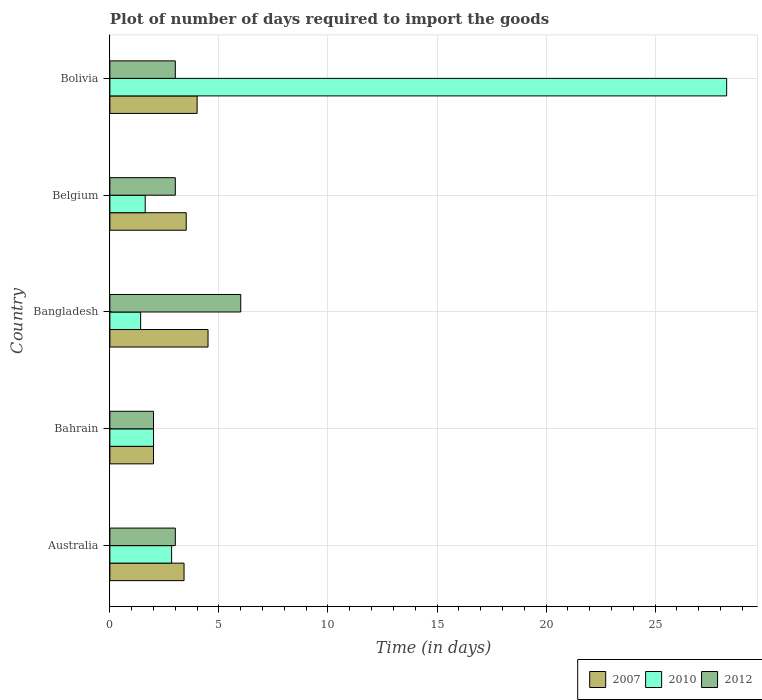How many groups of bars are there?
Your answer should be compact. 5. Are the number of bars per tick equal to the number of legend labels?
Keep it short and to the point. Yes. How many bars are there on the 5th tick from the bottom?
Your answer should be very brief. 3. What is the label of the 5th group of bars from the top?
Ensure brevity in your answer.  Australia. In how many cases, is the number of bars for a given country not equal to the number of legend labels?
Your answer should be compact. 0. What is the time required to import goods in 2007 in Belgium?
Give a very brief answer. 3.5. Across all countries, what is the minimum time required to import goods in 2010?
Keep it short and to the point. 1.41. In which country was the time required to import goods in 2012 maximum?
Offer a very short reply. Bangladesh. In which country was the time required to import goods in 2010 minimum?
Provide a short and direct response. Bangladesh. What is the difference between the time required to import goods in 2010 in Australia and that in Belgium?
Offer a very short reply. 1.21. What is the difference between the time required to import goods in 2012 in Bangladesh and the time required to import goods in 2010 in Australia?
Keep it short and to the point. 3.17. What is the average time required to import goods in 2010 per country?
Offer a very short reply. 7.23. What is the difference between the time required to import goods in 2007 and time required to import goods in 2010 in Bahrain?
Offer a very short reply. 0. Is the time required to import goods in 2007 in Bangladesh less than that in Bolivia?
Provide a short and direct response. No. What is the difference between the highest and the second highest time required to import goods in 2007?
Keep it short and to the point. 0.5. In how many countries, is the time required to import goods in 2010 greater than the average time required to import goods in 2010 taken over all countries?
Give a very brief answer. 1. Is the sum of the time required to import goods in 2007 in Bahrain and Bolivia greater than the maximum time required to import goods in 2012 across all countries?
Offer a very short reply. No. What does the 2nd bar from the top in Australia represents?
Provide a short and direct response. 2010. Is it the case that in every country, the sum of the time required to import goods in 2010 and time required to import goods in 2012 is greater than the time required to import goods in 2007?
Give a very brief answer. Yes. How many bars are there?
Make the answer very short. 15. What is the difference between two consecutive major ticks on the X-axis?
Make the answer very short. 5. What is the title of the graph?
Offer a terse response. Plot of number of days required to import the goods. What is the label or title of the X-axis?
Give a very brief answer. Time (in days). What is the Time (in days) of 2007 in Australia?
Make the answer very short. 3.4. What is the Time (in days) of 2010 in Australia?
Your answer should be compact. 2.83. What is the Time (in days) in 2007 in Bahrain?
Provide a succinct answer. 2. What is the Time (in days) of 2010 in Bahrain?
Your answer should be compact. 2. What is the Time (in days) of 2012 in Bahrain?
Your response must be concise. 2. What is the Time (in days) in 2010 in Bangladesh?
Make the answer very short. 1.41. What is the Time (in days) of 2012 in Bangladesh?
Provide a succinct answer. 6. What is the Time (in days) of 2010 in Belgium?
Keep it short and to the point. 1.62. What is the Time (in days) of 2007 in Bolivia?
Your answer should be compact. 4. What is the Time (in days) of 2010 in Bolivia?
Provide a succinct answer. 28.28. What is the Time (in days) in 2012 in Bolivia?
Give a very brief answer. 3. Across all countries, what is the maximum Time (in days) in 2010?
Offer a very short reply. 28.28. Across all countries, what is the minimum Time (in days) of 2010?
Your answer should be very brief. 1.41. Across all countries, what is the minimum Time (in days) of 2012?
Ensure brevity in your answer.  2. What is the total Time (in days) in 2010 in the graph?
Make the answer very short. 36.14. What is the difference between the Time (in days) in 2007 in Australia and that in Bahrain?
Offer a very short reply. 1.4. What is the difference between the Time (in days) of 2010 in Australia and that in Bahrain?
Keep it short and to the point. 0.83. What is the difference between the Time (in days) of 2012 in Australia and that in Bahrain?
Provide a short and direct response. 1. What is the difference between the Time (in days) of 2010 in Australia and that in Bangladesh?
Provide a short and direct response. 1.42. What is the difference between the Time (in days) of 2007 in Australia and that in Belgium?
Ensure brevity in your answer.  -0.1. What is the difference between the Time (in days) of 2010 in Australia and that in Belgium?
Your answer should be very brief. 1.21. What is the difference between the Time (in days) in 2012 in Australia and that in Belgium?
Provide a succinct answer. 0. What is the difference between the Time (in days) of 2010 in Australia and that in Bolivia?
Ensure brevity in your answer.  -25.45. What is the difference between the Time (in days) in 2012 in Australia and that in Bolivia?
Your response must be concise. 0. What is the difference between the Time (in days) of 2010 in Bahrain and that in Bangladesh?
Offer a terse response. 0.59. What is the difference between the Time (in days) in 2010 in Bahrain and that in Belgium?
Ensure brevity in your answer.  0.38. What is the difference between the Time (in days) in 2010 in Bahrain and that in Bolivia?
Provide a short and direct response. -26.28. What is the difference between the Time (in days) in 2010 in Bangladesh and that in Belgium?
Offer a terse response. -0.21. What is the difference between the Time (in days) in 2007 in Bangladesh and that in Bolivia?
Ensure brevity in your answer.  0.5. What is the difference between the Time (in days) of 2010 in Bangladesh and that in Bolivia?
Provide a short and direct response. -26.87. What is the difference between the Time (in days) of 2012 in Bangladesh and that in Bolivia?
Ensure brevity in your answer.  3. What is the difference between the Time (in days) of 2010 in Belgium and that in Bolivia?
Give a very brief answer. -26.66. What is the difference between the Time (in days) of 2007 in Australia and the Time (in days) of 2010 in Bahrain?
Make the answer very short. 1.4. What is the difference between the Time (in days) in 2007 in Australia and the Time (in days) in 2012 in Bahrain?
Give a very brief answer. 1.4. What is the difference between the Time (in days) in 2010 in Australia and the Time (in days) in 2012 in Bahrain?
Your answer should be very brief. 0.83. What is the difference between the Time (in days) in 2007 in Australia and the Time (in days) in 2010 in Bangladesh?
Your answer should be very brief. 1.99. What is the difference between the Time (in days) in 2010 in Australia and the Time (in days) in 2012 in Bangladesh?
Give a very brief answer. -3.17. What is the difference between the Time (in days) of 2007 in Australia and the Time (in days) of 2010 in Belgium?
Give a very brief answer. 1.78. What is the difference between the Time (in days) of 2007 in Australia and the Time (in days) of 2012 in Belgium?
Your answer should be very brief. 0.4. What is the difference between the Time (in days) of 2010 in Australia and the Time (in days) of 2012 in Belgium?
Offer a terse response. -0.17. What is the difference between the Time (in days) of 2007 in Australia and the Time (in days) of 2010 in Bolivia?
Your answer should be very brief. -24.88. What is the difference between the Time (in days) in 2007 in Australia and the Time (in days) in 2012 in Bolivia?
Your answer should be compact. 0.4. What is the difference between the Time (in days) of 2010 in Australia and the Time (in days) of 2012 in Bolivia?
Make the answer very short. -0.17. What is the difference between the Time (in days) of 2007 in Bahrain and the Time (in days) of 2010 in Bangladesh?
Provide a succinct answer. 0.59. What is the difference between the Time (in days) of 2010 in Bahrain and the Time (in days) of 2012 in Bangladesh?
Provide a short and direct response. -4. What is the difference between the Time (in days) of 2007 in Bahrain and the Time (in days) of 2010 in Belgium?
Ensure brevity in your answer.  0.38. What is the difference between the Time (in days) in 2010 in Bahrain and the Time (in days) in 2012 in Belgium?
Your response must be concise. -1. What is the difference between the Time (in days) of 2007 in Bahrain and the Time (in days) of 2010 in Bolivia?
Offer a very short reply. -26.28. What is the difference between the Time (in days) in 2010 in Bahrain and the Time (in days) in 2012 in Bolivia?
Keep it short and to the point. -1. What is the difference between the Time (in days) of 2007 in Bangladesh and the Time (in days) of 2010 in Belgium?
Your response must be concise. 2.88. What is the difference between the Time (in days) of 2007 in Bangladesh and the Time (in days) of 2012 in Belgium?
Your response must be concise. 1.5. What is the difference between the Time (in days) in 2010 in Bangladesh and the Time (in days) in 2012 in Belgium?
Offer a very short reply. -1.59. What is the difference between the Time (in days) of 2007 in Bangladesh and the Time (in days) of 2010 in Bolivia?
Make the answer very short. -23.78. What is the difference between the Time (in days) in 2010 in Bangladesh and the Time (in days) in 2012 in Bolivia?
Provide a short and direct response. -1.59. What is the difference between the Time (in days) of 2007 in Belgium and the Time (in days) of 2010 in Bolivia?
Provide a succinct answer. -24.78. What is the difference between the Time (in days) in 2007 in Belgium and the Time (in days) in 2012 in Bolivia?
Your answer should be very brief. 0.5. What is the difference between the Time (in days) in 2010 in Belgium and the Time (in days) in 2012 in Bolivia?
Provide a succinct answer. -1.38. What is the average Time (in days) in 2007 per country?
Offer a terse response. 3.48. What is the average Time (in days) in 2010 per country?
Provide a short and direct response. 7.23. What is the difference between the Time (in days) in 2007 and Time (in days) in 2010 in Australia?
Provide a short and direct response. 0.57. What is the difference between the Time (in days) of 2010 and Time (in days) of 2012 in Australia?
Your answer should be very brief. -0.17. What is the difference between the Time (in days) in 2007 and Time (in days) in 2010 in Bangladesh?
Keep it short and to the point. 3.09. What is the difference between the Time (in days) in 2007 and Time (in days) in 2012 in Bangladesh?
Provide a short and direct response. -1.5. What is the difference between the Time (in days) in 2010 and Time (in days) in 2012 in Bangladesh?
Give a very brief answer. -4.59. What is the difference between the Time (in days) of 2007 and Time (in days) of 2010 in Belgium?
Provide a succinct answer. 1.88. What is the difference between the Time (in days) of 2010 and Time (in days) of 2012 in Belgium?
Your answer should be very brief. -1.38. What is the difference between the Time (in days) in 2007 and Time (in days) in 2010 in Bolivia?
Your response must be concise. -24.28. What is the difference between the Time (in days) of 2007 and Time (in days) of 2012 in Bolivia?
Ensure brevity in your answer.  1. What is the difference between the Time (in days) of 2010 and Time (in days) of 2012 in Bolivia?
Your answer should be compact. 25.28. What is the ratio of the Time (in days) of 2007 in Australia to that in Bahrain?
Make the answer very short. 1.7. What is the ratio of the Time (in days) of 2010 in Australia to that in Bahrain?
Provide a short and direct response. 1.42. What is the ratio of the Time (in days) of 2012 in Australia to that in Bahrain?
Offer a terse response. 1.5. What is the ratio of the Time (in days) in 2007 in Australia to that in Bangladesh?
Give a very brief answer. 0.76. What is the ratio of the Time (in days) of 2010 in Australia to that in Bangladesh?
Give a very brief answer. 2.01. What is the ratio of the Time (in days) of 2012 in Australia to that in Bangladesh?
Your response must be concise. 0.5. What is the ratio of the Time (in days) of 2007 in Australia to that in Belgium?
Offer a very short reply. 0.97. What is the ratio of the Time (in days) of 2010 in Australia to that in Belgium?
Provide a succinct answer. 1.75. What is the ratio of the Time (in days) in 2012 in Australia to that in Belgium?
Your answer should be very brief. 1. What is the ratio of the Time (in days) in 2010 in Australia to that in Bolivia?
Your answer should be very brief. 0.1. What is the ratio of the Time (in days) in 2012 in Australia to that in Bolivia?
Provide a short and direct response. 1. What is the ratio of the Time (in days) of 2007 in Bahrain to that in Bangladesh?
Make the answer very short. 0.44. What is the ratio of the Time (in days) in 2010 in Bahrain to that in Bangladesh?
Ensure brevity in your answer.  1.42. What is the ratio of the Time (in days) in 2007 in Bahrain to that in Belgium?
Give a very brief answer. 0.57. What is the ratio of the Time (in days) in 2010 in Bahrain to that in Belgium?
Your answer should be compact. 1.23. What is the ratio of the Time (in days) in 2007 in Bahrain to that in Bolivia?
Offer a terse response. 0.5. What is the ratio of the Time (in days) of 2010 in Bahrain to that in Bolivia?
Keep it short and to the point. 0.07. What is the ratio of the Time (in days) in 2010 in Bangladesh to that in Belgium?
Offer a terse response. 0.87. What is the ratio of the Time (in days) of 2010 in Bangladesh to that in Bolivia?
Keep it short and to the point. 0.05. What is the ratio of the Time (in days) in 2012 in Bangladesh to that in Bolivia?
Give a very brief answer. 2. What is the ratio of the Time (in days) of 2007 in Belgium to that in Bolivia?
Offer a terse response. 0.88. What is the ratio of the Time (in days) in 2010 in Belgium to that in Bolivia?
Provide a succinct answer. 0.06. What is the difference between the highest and the second highest Time (in days) in 2007?
Provide a succinct answer. 0.5. What is the difference between the highest and the second highest Time (in days) in 2010?
Your response must be concise. 25.45. What is the difference between the highest and the lowest Time (in days) in 2010?
Your answer should be very brief. 26.87. 